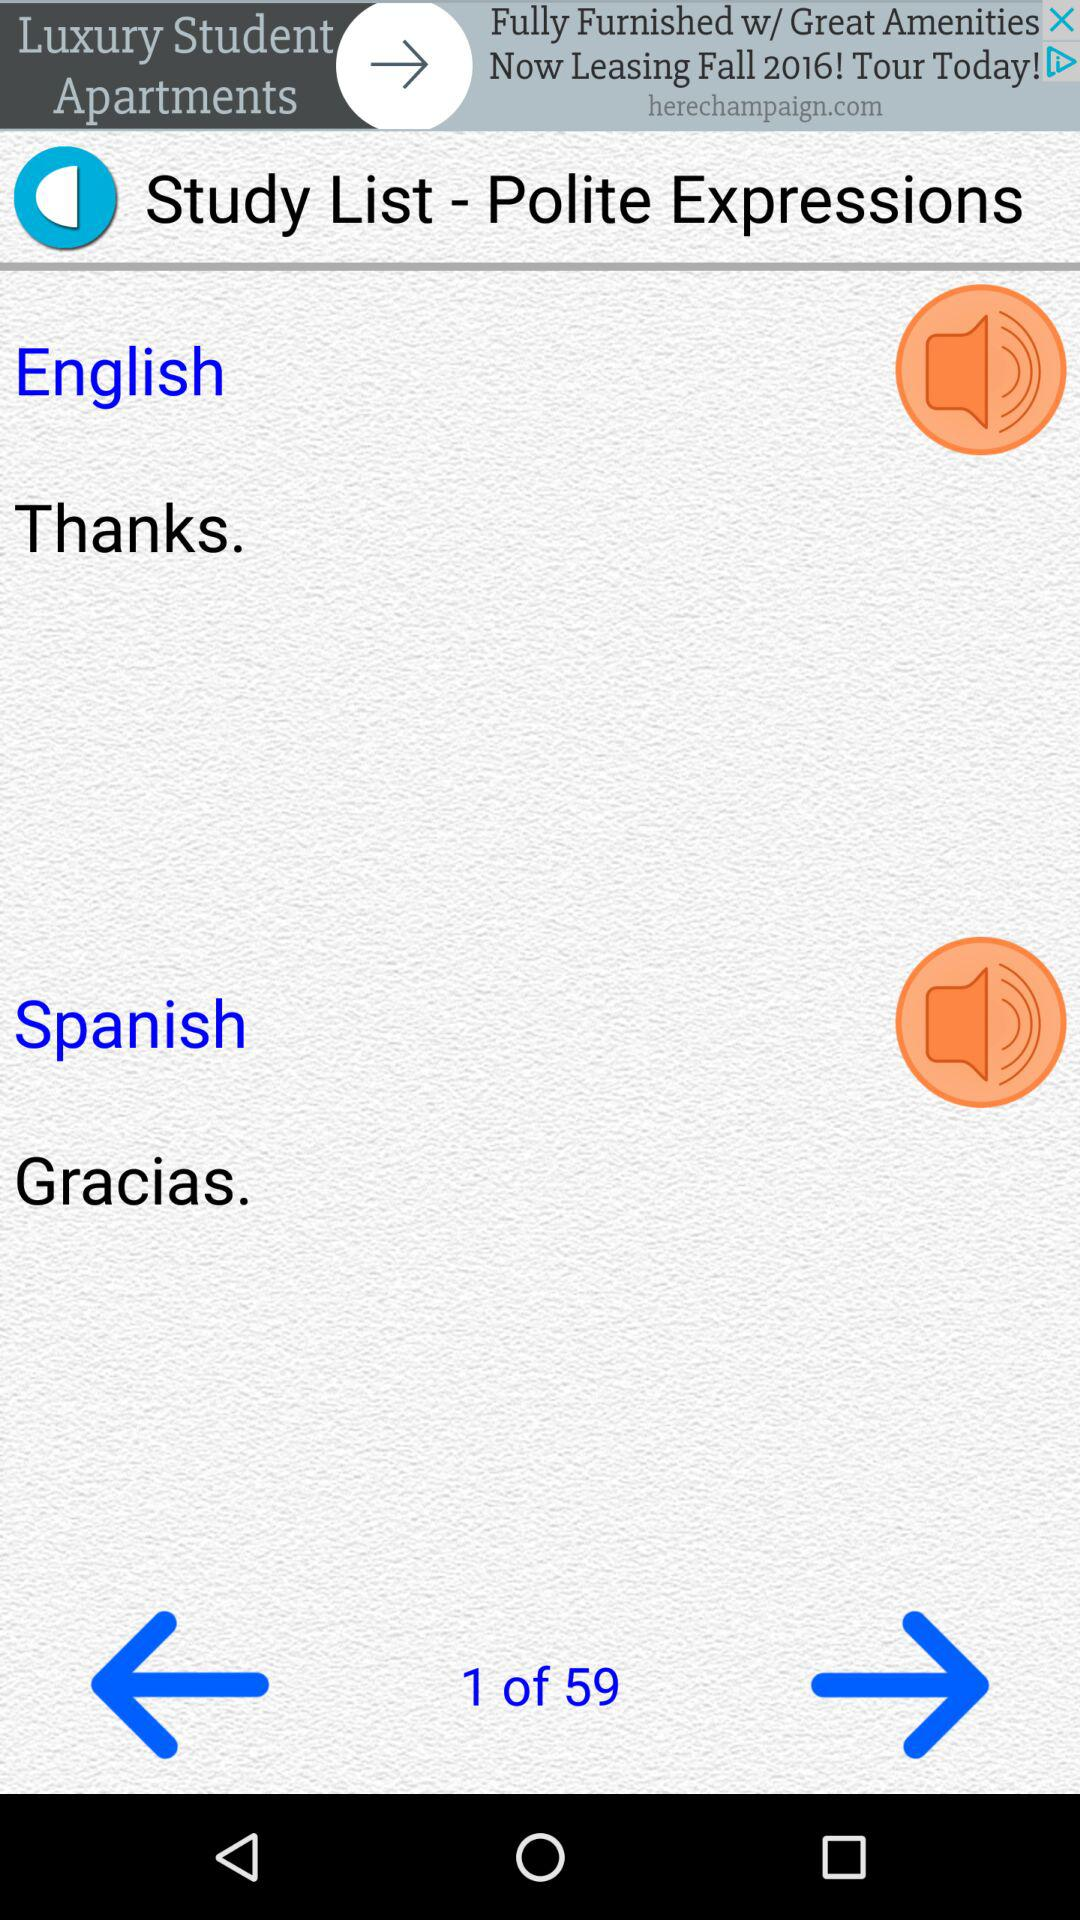What is the current page number? The current page number is 1. 